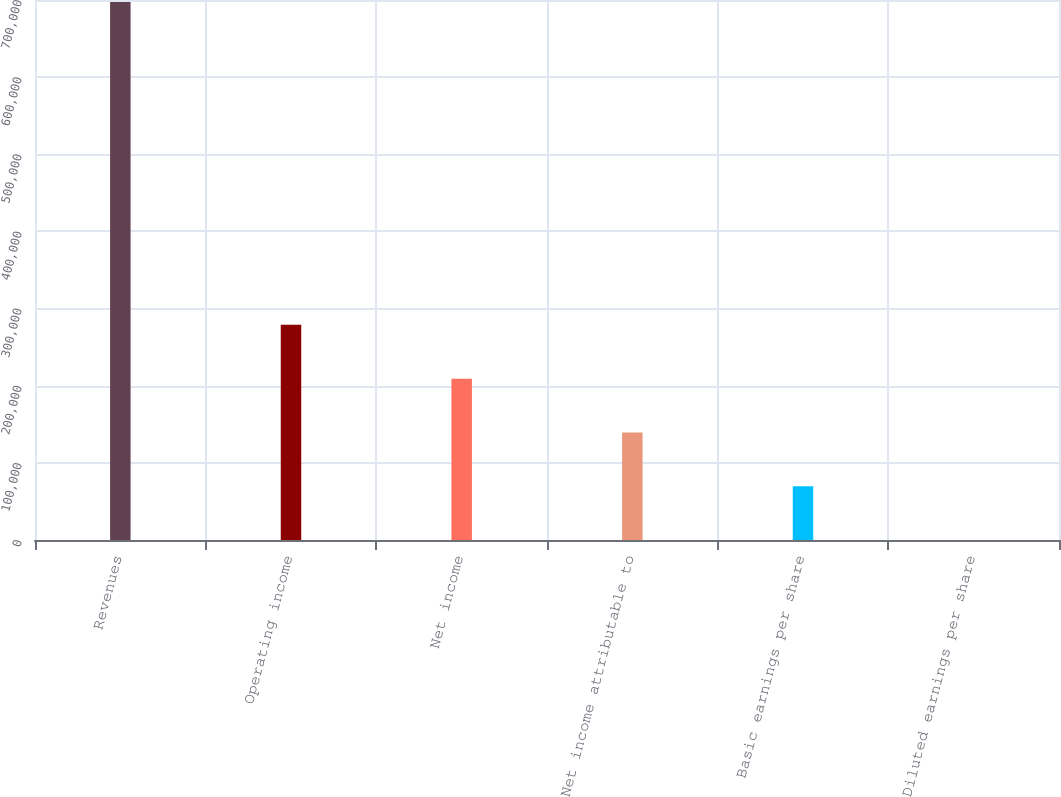<chart> <loc_0><loc_0><loc_500><loc_500><bar_chart><fcel>Revenues<fcel>Operating income<fcel>Net income<fcel>Net income attributable to<fcel>Basic earnings per share<fcel>Diluted earnings per share<nl><fcel>697291<fcel>278917<fcel>209188<fcel>139459<fcel>69730.1<fcel>1.1<nl></chart> 